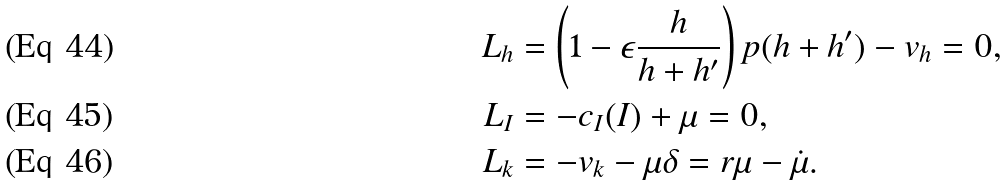<formula> <loc_0><loc_0><loc_500><loc_500>L _ { h } & = \left ( 1 - \epsilon \frac { h } { h + h ^ { \prime } } \right ) p ( h + h ^ { \prime } ) - v _ { h } = 0 , \\ L _ { I } & = - c _ { I } ( I ) + \mu = 0 , \\ L _ { k } & = - v _ { k } - \mu \delta = r \mu - \dot { \mu } .</formula> 